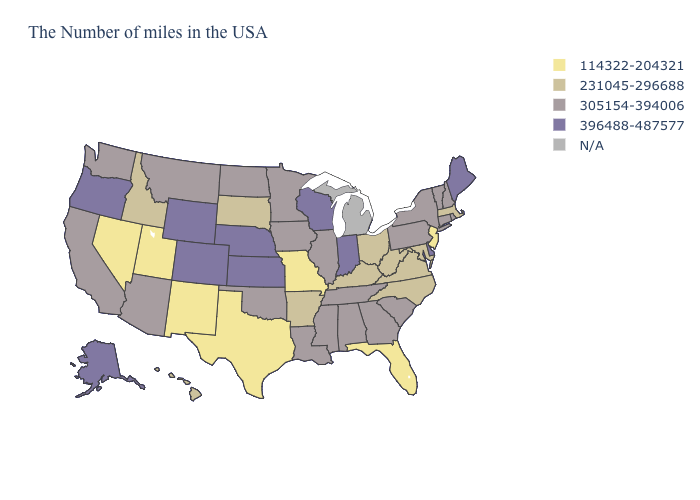Name the states that have a value in the range 231045-296688?
Write a very short answer. Massachusetts, Maryland, Virginia, North Carolina, West Virginia, Ohio, Kentucky, Arkansas, South Dakota, Idaho, Hawaii. Which states hav the highest value in the West?
Be succinct. Wyoming, Colorado, Oregon, Alaska. Among the states that border Delaware , which have the highest value?
Concise answer only. Pennsylvania. What is the value of Minnesota?
Quick response, please. 305154-394006. Which states hav the highest value in the MidWest?
Answer briefly. Indiana, Wisconsin, Kansas, Nebraska. Which states have the lowest value in the Northeast?
Short answer required. New Jersey. What is the value of Nebraska?
Concise answer only. 396488-487577. What is the lowest value in states that border Arizona?
Concise answer only. 114322-204321. Is the legend a continuous bar?
Give a very brief answer. No. Name the states that have a value in the range N/A?
Concise answer only. Michigan. Does Delaware have the highest value in the South?
Short answer required. Yes. Name the states that have a value in the range 114322-204321?
Answer briefly. New Jersey, Florida, Missouri, Texas, New Mexico, Utah, Nevada. Among the states that border Alabama , does Georgia have the highest value?
Concise answer only. Yes. What is the value of Louisiana?
Quick response, please. 305154-394006. 